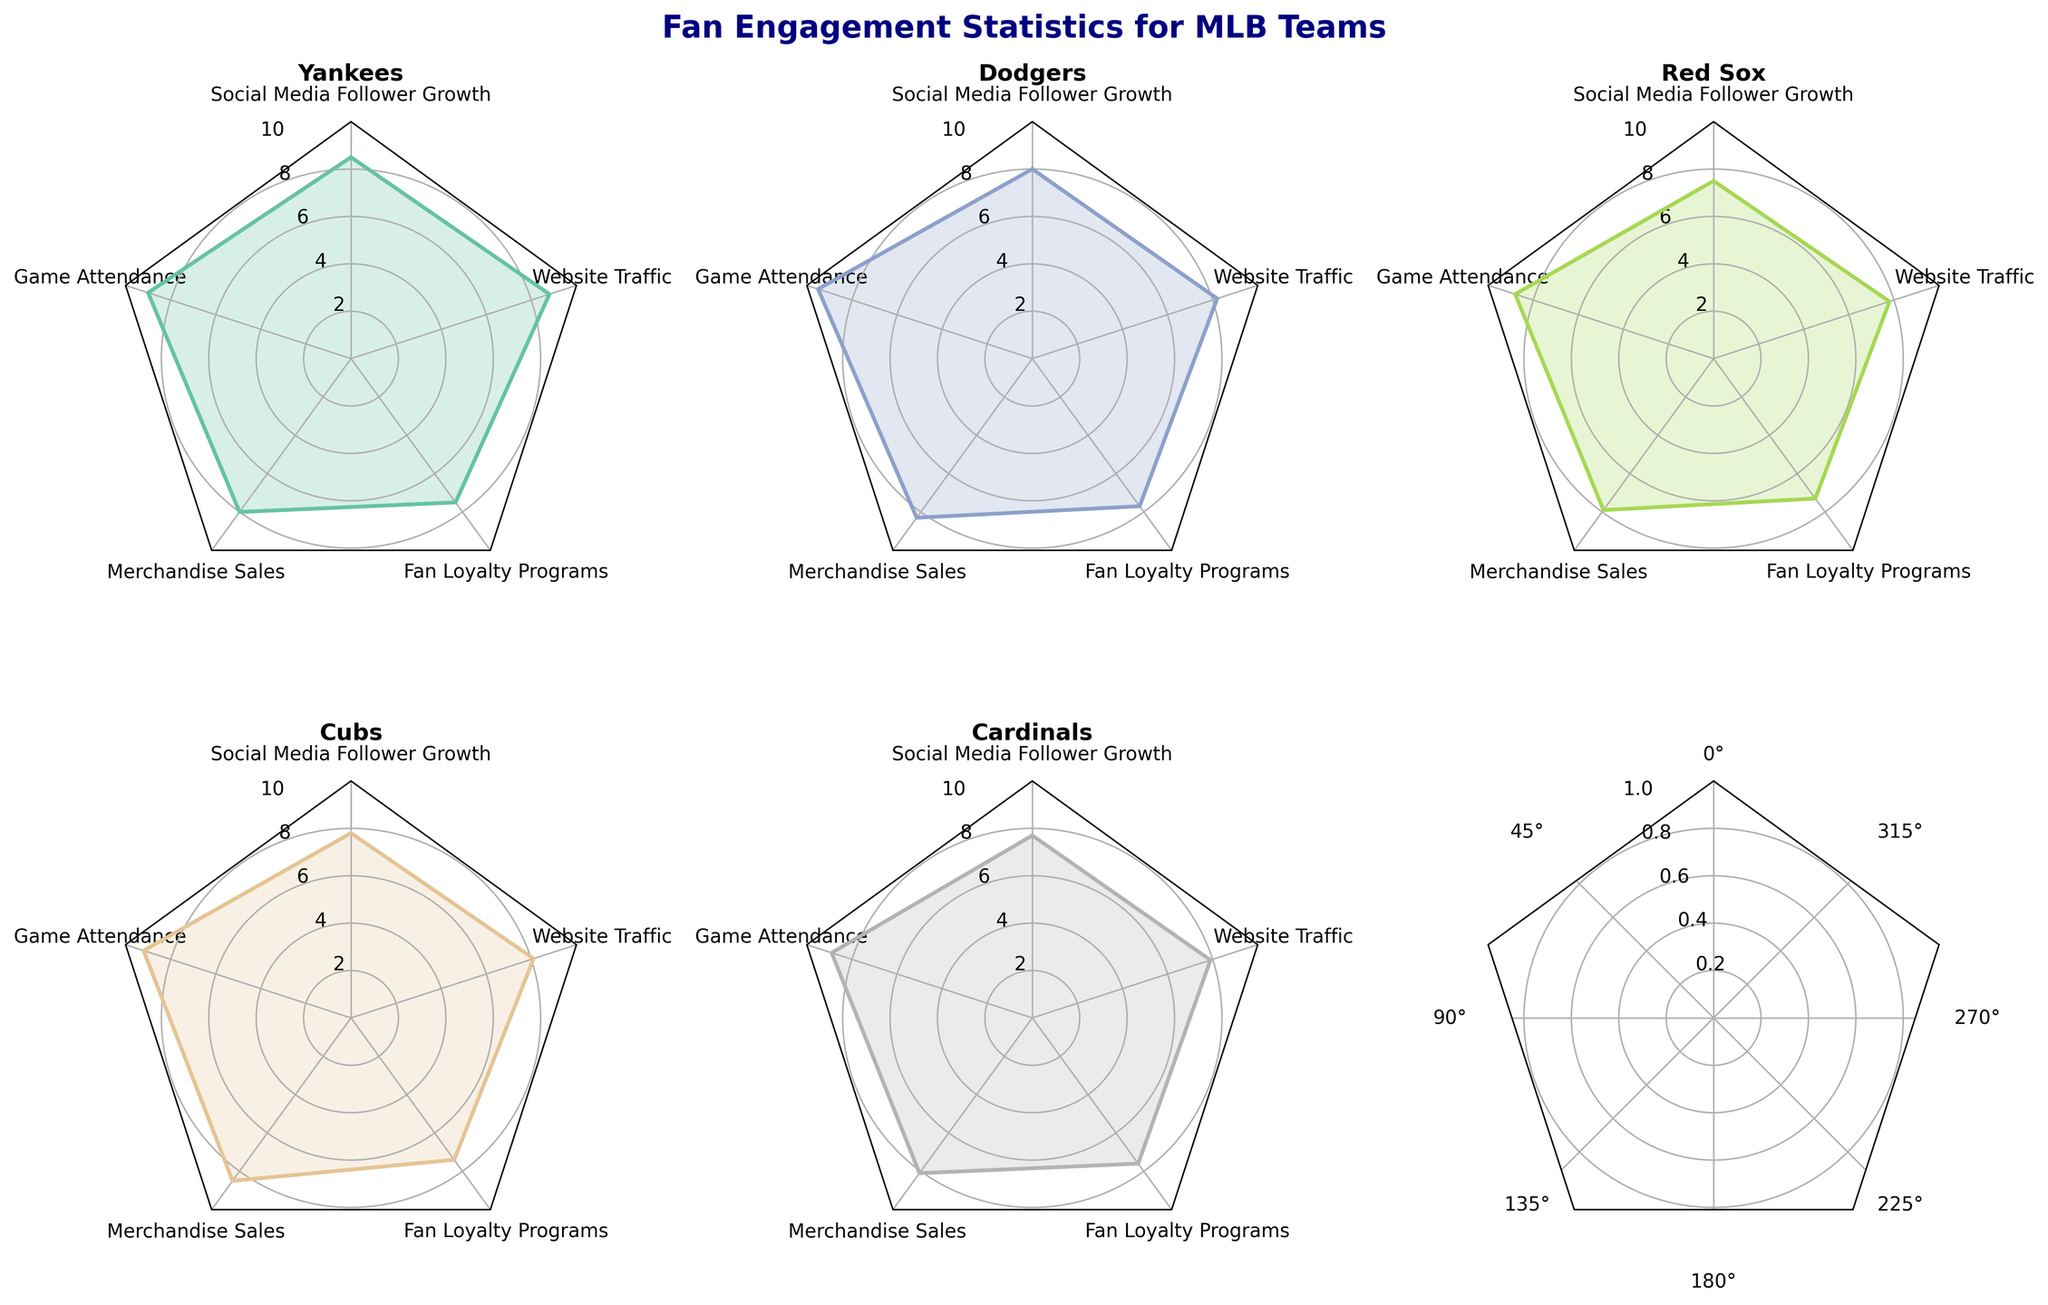Which team has the highest game attendance? According to the radar charts for each team, the Dodgers have the highest game attendance value at 9.5.
Answer: Dodgers What is the average value of social media follower growth across all teams? Calculate the average by adding the social media follower growth values for all teams and dividing by the number of teams. (8.5 + 8.0 + 7.5 + 7.8 + 7.7) / 5 = 39.5 / 5 = 7.9
Answer: 7.9 Which team has the lowest merchandise sales? The radar charts show that the Red Sox have the lowest merchandise sales value at 7.9.
Answer: Red Sox How does the Yankees' website traffic compare to the Cardinals' website traffic? The Yankees' website traffic is 8.8, while the Cardinals' is 7.9. Therefore, the Yankees have a higher website traffic value than the Cardinals.
Answer: Yankees have higher website traffic What is the total value of fan loyalty programs across the Red Sox, Cubs, and Cardinals? Adding the fan loyalty programs values for the Red Sox, Cubs, and Cardinals: 7.3 + 7.4 + 7.6 = 22.3
Answer: 22.3 Which category has the greatest range of values across all teams, and what is that range? The category "Game Attendance" shows the greatest range of values across all teams. The highest is the Dodgers at 9.5 and the lowest is the Red Sox at 8.8, so the range is 9.5 - 8.8 = 0.7
Answer: Game Attendance, 0.7 Between the Cubs and Yankees, which team has a higher value for merchandise sales and by how much? The Cubs have a merchandise sales value of 8.5, while the Yankees have a value of 8.0. The difference is 8.5 - 8.0 = 0.5.
Answer: Cubs by 0.5 Which team has the most balanced (least variation) engagement across the five categories? Based on the visual inspection of the radar charts, the team with the most balanced engagement across the categories appears to be the Cardinals, as their values are relatively even and close to each other.
Answer: Cardinals 